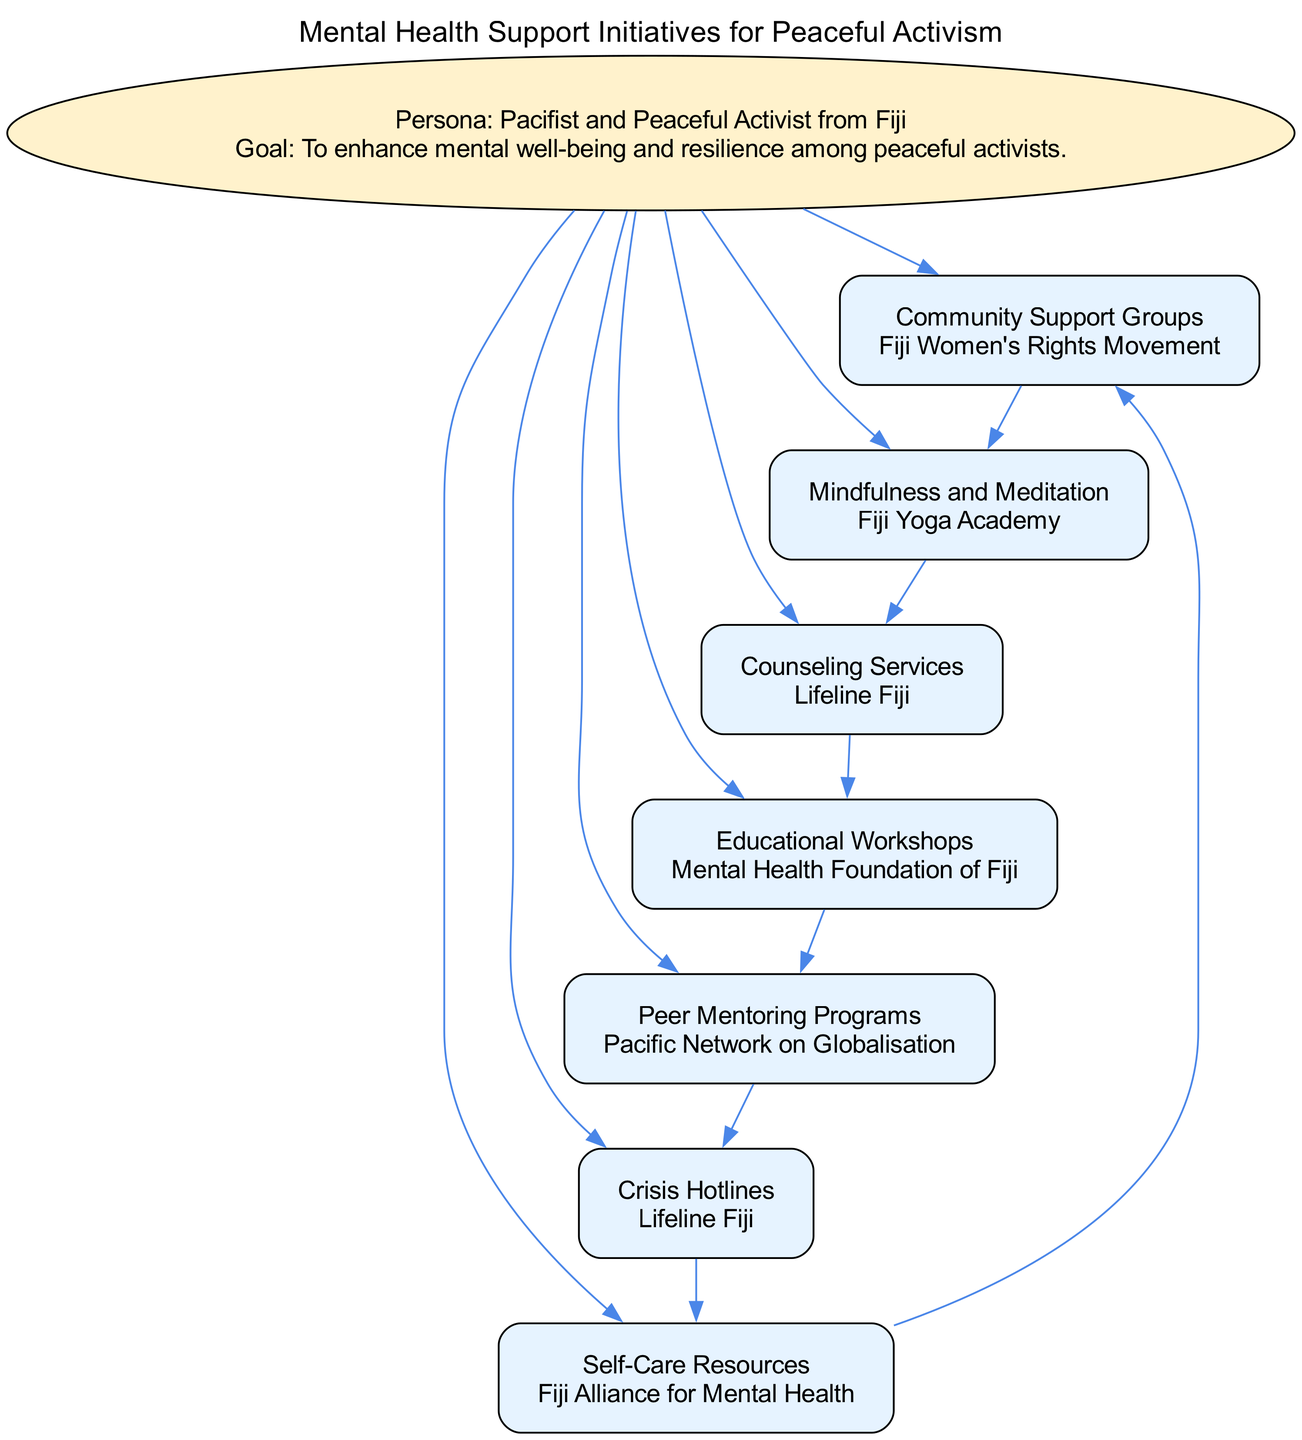What is the main goal of the pathway? The pathway's goal is stated in the introduction and focuses on enhancing mental well-being and resilience among peaceful activists.
Answer: Enhance mental well-being and resilience How many elements are in the diagram? There are seven distinct elements listed in the diagram, each representing a type of mental health support initiative.
Answer: Seven Which element connects to Counseling Services? The diagram shows that Mindfulness and Meditation connects directly to Counseling Services.
Answer: Mindfulness and Meditation What organization is associated with Community Support Groups? The example entity listed for Community Support Groups in the diagram is the Fiji Women's Rights Movement.
Answer: Fiji Women's Rights Movement Which element comes after Peer Mentoring in the sequence? By following the flow in the diagram, the element that follows Peer Mentoring is Crisis Hotlines.
Answer: Crisis Hotlines What is the relationship between Self-Care Resources and Community Support Groups? The diagram indicates a bidirectional connection; Self-Care Resources leads back to Community Support Groups.
Answer: Bidirectional connection What type of support does Crisis Hotlines provide? The description for Crisis Hotlines specifies that it offers immediate support in times of emotional distress.
Answer: Immediate support Which organization offers access to Counseling Services? The example entity associated with Counseling Services in the diagram is Lifeline Fiji.
Answer: Lifeline Fiji 